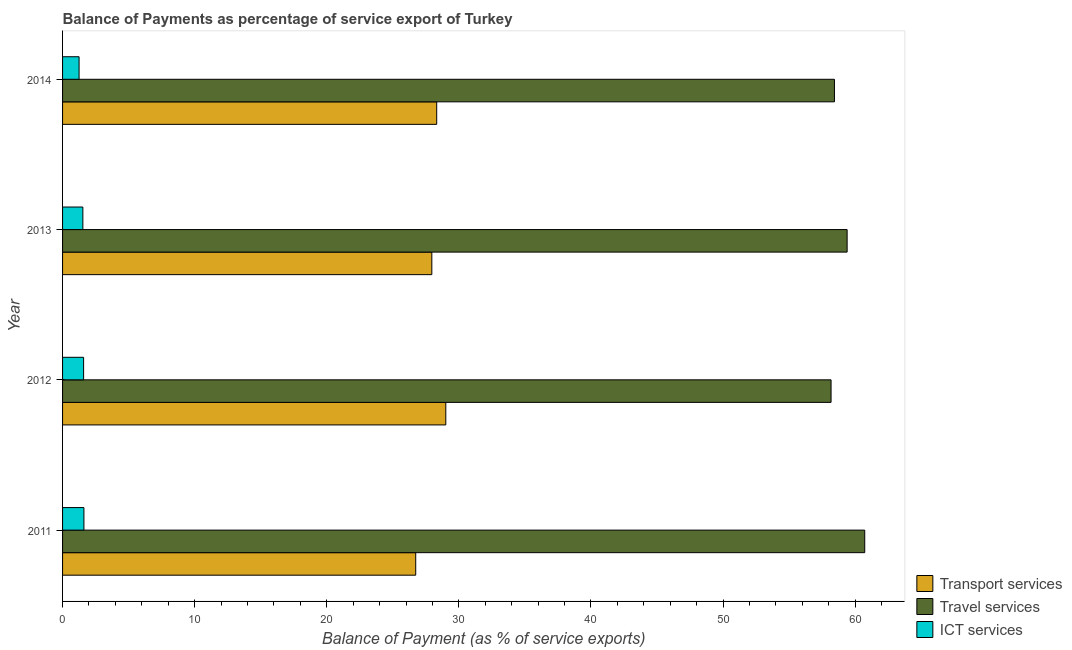How many different coloured bars are there?
Ensure brevity in your answer.  3. How many groups of bars are there?
Keep it short and to the point. 4. In how many cases, is the number of bars for a given year not equal to the number of legend labels?
Provide a succinct answer. 0. What is the balance of payment of travel services in 2011?
Your answer should be very brief. 60.73. Across all years, what is the maximum balance of payment of travel services?
Offer a very short reply. 60.73. Across all years, what is the minimum balance of payment of transport services?
Offer a terse response. 26.73. In which year was the balance of payment of transport services maximum?
Provide a short and direct response. 2012. In which year was the balance of payment of transport services minimum?
Your response must be concise. 2011. What is the total balance of payment of transport services in the graph?
Keep it short and to the point. 112.02. What is the difference between the balance of payment of ict services in 2012 and that in 2013?
Keep it short and to the point. 0.06. What is the difference between the balance of payment of transport services in 2013 and the balance of payment of travel services in 2012?
Your answer should be very brief. -30.22. What is the average balance of payment of ict services per year?
Offer a terse response. 1.5. In the year 2012, what is the difference between the balance of payment of transport services and balance of payment of travel services?
Give a very brief answer. -29.16. What is the ratio of the balance of payment of travel services in 2013 to that in 2014?
Your response must be concise. 1.02. Is the balance of payment of transport services in 2013 less than that in 2014?
Provide a succinct answer. Yes. What is the difference between the highest and the second highest balance of payment of ict services?
Your answer should be very brief. 0.02. What is the difference between the highest and the lowest balance of payment of travel services?
Make the answer very short. 2.55. In how many years, is the balance of payment of transport services greater than the average balance of payment of transport services taken over all years?
Provide a short and direct response. 2. What does the 3rd bar from the top in 2011 represents?
Provide a succinct answer. Transport services. What does the 3rd bar from the bottom in 2011 represents?
Offer a terse response. ICT services. Are the values on the major ticks of X-axis written in scientific E-notation?
Give a very brief answer. No. Where does the legend appear in the graph?
Your answer should be very brief. Bottom right. What is the title of the graph?
Ensure brevity in your answer.  Balance of Payments as percentage of service export of Turkey. Does "Hydroelectric sources" appear as one of the legend labels in the graph?
Keep it short and to the point. No. What is the label or title of the X-axis?
Provide a succinct answer. Balance of Payment (as % of service exports). What is the label or title of the Y-axis?
Your answer should be very brief. Year. What is the Balance of Payment (as % of service exports) in Transport services in 2011?
Your response must be concise. 26.73. What is the Balance of Payment (as % of service exports) in Travel services in 2011?
Keep it short and to the point. 60.73. What is the Balance of Payment (as % of service exports) of ICT services in 2011?
Provide a succinct answer. 1.62. What is the Balance of Payment (as % of service exports) in Transport services in 2012?
Your answer should be very brief. 29.01. What is the Balance of Payment (as % of service exports) in Travel services in 2012?
Provide a succinct answer. 58.18. What is the Balance of Payment (as % of service exports) in ICT services in 2012?
Provide a short and direct response. 1.59. What is the Balance of Payment (as % of service exports) of Transport services in 2013?
Give a very brief answer. 27.95. What is the Balance of Payment (as % of service exports) of Travel services in 2013?
Keep it short and to the point. 59.39. What is the Balance of Payment (as % of service exports) of ICT services in 2013?
Provide a short and direct response. 1.54. What is the Balance of Payment (as % of service exports) in Transport services in 2014?
Offer a very short reply. 28.32. What is the Balance of Payment (as % of service exports) of Travel services in 2014?
Your response must be concise. 58.43. What is the Balance of Payment (as % of service exports) of ICT services in 2014?
Offer a terse response. 1.25. Across all years, what is the maximum Balance of Payment (as % of service exports) of Transport services?
Offer a terse response. 29.01. Across all years, what is the maximum Balance of Payment (as % of service exports) in Travel services?
Provide a short and direct response. 60.73. Across all years, what is the maximum Balance of Payment (as % of service exports) in ICT services?
Ensure brevity in your answer.  1.62. Across all years, what is the minimum Balance of Payment (as % of service exports) of Transport services?
Make the answer very short. 26.73. Across all years, what is the minimum Balance of Payment (as % of service exports) of Travel services?
Your response must be concise. 58.18. Across all years, what is the minimum Balance of Payment (as % of service exports) in ICT services?
Make the answer very short. 1.25. What is the total Balance of Payment (as % of service exports) of Transport services in the graph?
Offer a terse response. 112.02. What is the total Balance of Payment (as % of service exports) of Travel services in the graph?
Ensure brevity in your answer.  236.73. What is the total Balance of Payment (as % of service exports) of ICT services in the graph?
Your answer should be compact. 6. What is the difference between the Balance of Payment (as % of service exports) of Transport services in 2011 and that in 2012?
Provide a short and direct response. -2.28. What is the difference between the Balance of Payment (as % of service exports) of Travel services in 2011 and that in 2012?
Give a very brief answer. 2.55. What is the difference between the Balance of Payment (as % of service exports) in ICT services in 2011 and that in 2012?
Provide a succinct answer. 0.02. What is the difference between the Balance of Payment (as % of service exports) in Transport services in 2011 and that in 2013?
Provide a succinct answer. -1.22. What is the difference between the Balance of Payment (as % of service exports) in Travel services in 2011 and that in 2013?
Offer a very short reply. 1.33. What is the difference between the Balance of Payment (as % of service exports) of ICT services in 2011 and that in 2013?
Keep it short and to the point. 0.08. What is the difference between the Balance of Payment (as % of service exports) of Transport services in 2011 and that in 2014?
Offer a terse response. -1.59. What is the difference between the Balance of Payment (as % of service exports) of Travel services in 2011 and that in 2014?
Offer a terse response. 2.29. What is the difference between the Balance of Payment (as % of service exports) in ICT services in 2011 and that in 2014?
Ensure brevity in your answer.  0.37. What is the difference between the Balance of Payment (as % of service exports) in Transport services in 2012 and that in 2013?
Make the answer very short. 1.06. What is the difference between the Balance of Payment (as % of service exports) in Travel services in 2012 and that in 2013?
Keep it short and to the point. -1.22. What is the difference between the Balance of Payment (as % of service exports) in ICT services in 2012 and that in 2013?
Keep it short and to the point. 0.06. What is the difference between the Balance of Payment (as % of service exports) in Transport services in 2012 and that in 2014?
Offer a terse response. 0.69. What is the difference between the Balance of Payment (as % of service exports) of Travel services in 2012 and that in 2014?
Your response must be concise. -0.26. What is the difference between the Balance of Payment (as % of service exports) of ICT services in 2012 and that in 2014?
Offer a very short reply. 0.34. What is the difference between the Balance of Payment (as % of service exports) in Transport services in 2013 and that in 2014?
Keep it short and to the point. -0.37. What is the difference between the Balance of Payment (as % of service exports) in Travel services in 2013 and that in 2014?
Offer a terse response. 0.96. What is the difference between the Balance of Payment (as % of service exports) in ICT services in 2013 and that in 2014?
Your response must be concise. 0.29. What is the difference between the Balance of Payment (as % of service exports) of Transport services in 2011 and the Balance of Payment (as % of service exports) of Travel services in 2012?
Your response must be concise. -31.44. What is the difference between the Balance of Payment (as % of service exports) of Transport services in 2011 and the Balance of Payment (as % of service exports) of ICT services in 2012?
Make the answer very short. 25.14. What is the difference between the Balance of Payment (as % of service exports) in Travel services in 2011 and the Balance of Payment (as % of service exports) in ICT services in 2012?
Your answer should be very brief. 59.13. What is the difference between the Balance of Payment (as % of service exports) in Transport services in 2011 and the Balance of Payment (as % of service exports) in Travel services in 2013?
Provide a short and direct response. -32.66. What is the difference between the Balance of Payment (as % of service exports) of Transport services in 2011 and the Balance of Payment (as % of service exports) of ICT services in 2013?
Provide a short and direct response. 25.2. What is the difference between the Balance of Payment (as % of service exports) of Travel services in 2011 and the Balance of Payment (as % of service exports) of ICT services in 2013?
Give a very brief answer. 59.19. What is the difference between the Balance of Payment (as % of service exports) in Transport services in 2011 and the Balance of Payment (as % of service exports) in Travel services in 2014?
Give a very brief answer. -31.7. What is the difference between the Balance of Payment (as % of service exports) in Transport services in 2011 and the Balance of Payment (as % of service exports) in ICT services in 2014?
Keep it short and to the point. 25.48. What is the difference between the Balance of Payment (as % of service exports) in Travel services in 2011 and the Balance of Payment (as % of service exports) in ICT services in 2014?
Your answer should be very brief. 59.48. What is the difference between the Balance of Payment (as % of service exports) of Transport services in 2012 and the Balance of Payment (as % of service exports) of Travel services in 2013?
Offer a terse response. -30.38. What is the difference between the Balance of Payment (as % of service exports) of Transport services in 2012 and the Balance of Payment (as % of service exports) of ICT services in 2013?
Make the answer very short. 27.48. What is the difference between the Balance of Payment (as % of service exports) in Travel services in 2012 and the Balance of Payment (as % of service exports) in ICT services in 2013?
Your response must be concise. 56.64. What is the difference between the Balance of Payment (as % of service exports) in Transport services in 2012 and the Balance of Payment (as % of service exports) in Travel services in 2014?
Keep it short and to the point. -29.42. What is the difference between the Balance of Payment (as % of service exports) of Transport services in 2012 and the Balance of Payment (as % of service exports) of ICT services in 2014?
Keep it short and to the point. 27.76. What is the difference between the Balance of Payment (as % of service exports) in Travel services in 2012 and the Balance of Payment (as % of service exports) in ICT services in 2014?
Your response must be concise. 56.93. What is the difference between the Balance of Payment (as % of service exports) of Transport services in 2013 and the Balance of Payment (as % of service exports) of Travel services in 2014?
Offer a terse response. -30.48. What is the difference between the Balance of Payment (as % of service exports) in Transport services in 2013 and the Balance of Payment (as % of service exports) in ICT services in 2014?
Provide a succinct answer. 26.7. What is the difference between the Balance of Payment (as % of service exports) in Travel services in 2013 and the Balance of Payment (as % of service exports) in ICT services in 2014?
Your answer should be compact. 58.14. What is the average Balance of Payment (as % of service exports) in Transport services per year?
Your answer should be compact. 28.01. What is the average Balance of Payment (as % of service exports) of Travel services per year?
Keep it short and to the point. 59.18. What is the average Balance of Payment (as % of service exports) of ICT services per year?
Keep it short and to the point. 1.5. In the year 2011, what is the difference between the Balance of Payment (as % of service exports) of Transport services and Balance of Payment (as % of service exports) of Travel services?
Your answer should be compact. -33.99. In the year 2011, what is the difference between the Balance of Payment (as % of service exports) of Transport services and Balance of Payment (as % of service exports) of ICT services?
Offer a very short reply. 25.12. In the year 2011, what is the difference between the Balance of Payment (as % of service exports) in Travel services and Balance of Payment (as % of service exports) in ICT services?
Ensure brevity in your answer.  59.11. In the year 2012, what is the difference between the Balance of Payment (as % of service exports) of Transport services and Balance of Payment (as % of service exports) of Travel services?
Your response must be concise. -29.16. In the year 2012, what is the difference between the Balance of Payment (as % of service exports) in Transport services and Balance of Payment (as % of service exports) in ICT services?
Ensure brevity in your answer.  27.42. In the year 2012, what is the difference between the Balance of Payment (as % of service exports) of Travel services and Balance of Payment (as % of service exports) of ICT services?
Ensure brevity in your answer.  56.58. In the year 2013, what is the difference between the Balance of Payment (as % of service exports) of Transport services and Balance of Payment (as % of service exports) of Travel services?
Your response must be concise. -31.44. In the year 2013, what is the difference between the Balance of Payment (as % of service exports) in Transport services and Balance of Payment (as % of service exports) in ICT services?
Offer a very short reply. 26.42. In the year 2013, what is the difference between the Balance of Payment (as % of service exports) of Travel services and Balance of Payment (as % of service exports) of ICT services?
Offer a very short reply. 57.86. In the year 2014, what is the difference between the Balance of Payment (as % of service exports) in Transport services and Balance of Payment (as % of service exports) in Travel services?
Your response must be concise. -30.11. In the year 2014, what is the difference between the Balance of Payment (as % of service exports) in Transport services and Balance of Payment (as % of service exports) in ICT services?
Offer a very short reply. 27.07. In the year 2014, what is the difference between the Balance of Payment (as % of service exports) in Travel services and Balance of Payment (as % of service exports) in ICT services?
Ensure brevity in your answer.  57.18. What is the ratio of the Balance of Payment (as % of service exports) of Transport services in 2011 to that in 2012?
Your answer should be very brief. 0.92. What is the ratio of the Balance of Payment (as % of service exports) in Travel services in 2011 to that in 2012?
Offer a very short reply. 1.04. What is the ratio of the Balance of Payment (as % of service exports) in ICT services in 2011 to that in 2012?
Make the answer very short. 1.01. What is the ratio of the Balance of Payment (as % of service exports) of Transport services in 2011 to that in 2013?
Provide a succinct answer. 0.96. What is the ratio of the Balance of Payment (as % of service exports) of Travel services in 2011 to that in 2013?
Provide a short and direct response. 1.02. What is the ratio of the Balance of Payment (as % of service exports) of ICT services in 2011 to that in 2013?
Your answer should be very brief. 1.05. What is the ratio of the Balance of Payment (as % of service exports) of Transport services in 2011 to that in 2014?
Ensure brevity in your answer.  0.94. What is the ratio of the Balance of Payment (as % of service exports) of Travel services in 2011 to that in 2014?
Ensure brevity in your answer.  1.04. What is the ratio of the Balance of Payment (as % of service exports) of ICT services in 2011 to that in 2014?
Keep it short and to the point. 1.29. What is the ratio of the Balance of Payment (as % of service exports) in Transport services in 2012 to that in 2013?
Your answer should be compact. 1.04. What is the ratio of the Balance of Payment (as % of service exports) in Travel services in 2012 to that in 2013?
Your response must be concise. 0.98. What is the ratio of the Balance of Payment (as % of service exports) of ICT services in 2012 to that in 2013?
Give a very brief answer. 1.04. What is the ratio of the Balance of Payment (as % of service exports) in Transport services in 2012 to that in 2014?
Your answer should be compact. 1.02. What is the ratio of the Balance of Payment (as % of service exports) in ICT services in 2012 to that in 2014?
Offer a terse response. 1.27. What is the ratio of the Balance of Payment (as % of service exports) in Travel services in 2013 to that in 2014?
Provide a short and direct response. 1.02. What is the ratio of the Balance of Payment (as % of service exports) of ICT services in 2013 to that in 2014?
Provide a short and direct response. 1.23. What is the difference between the highest and the second highest Balance of Payment (as % of service exports) in Transport services?
Your response must be concise. 0.69. What is the difference between the highest and the second highest Balance of Payment (as % of service exports) in Travel services?
Keep it short and to the point. 1.33. What is the difference between the highest and the second highest Balance of Payment (as % of service exports) of ICT services?
Provide a succinct answer. 0.02. What is the difference between the highest and the lowest Balance of Payment (as % of service exports) in Transport services?
Provide a short and direct response. 2.28. What is the difference between the highest and the lowest Balance of Payment (as % of service exports) in Travel services?
Give a very brief answer. 2.55. What is the difference between the highest and the lowest Balance of Payment (as % of service exports) in ICT services?
Give a very brief answer. 0.37. 